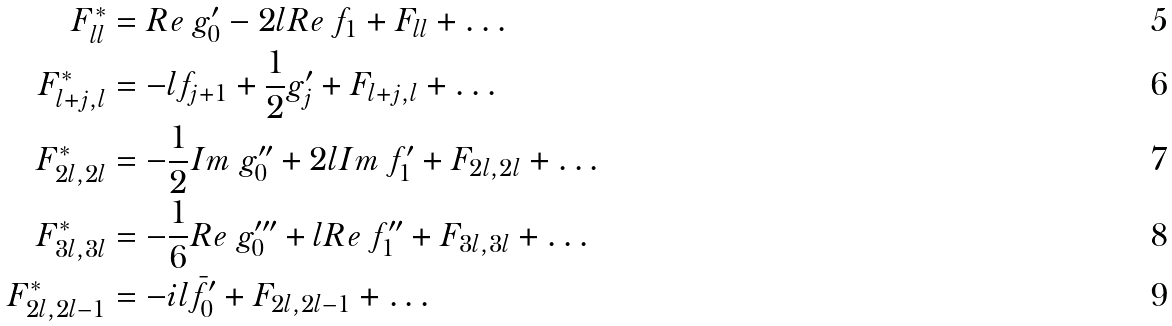<formula> <loc_0><loc_0><loc_500><loc_500>F ^ { * } _ { l l } & = R e \ g ^ { \prime } _ { 0 } - 2 l R e \ f _ { 1 } + F _ { l l } + \dots \\ F ^ { * } _ { l + j , l } & = - l f _ { j + 1 } + \frac { 1 } { 2 } g ^ { \prime } _ { j } + F _ { l + j , l } + \dots \\ F ^ { * } _ { 2 l , 2 l } & = - \frac { 1 } { 2 } I m \ g ^ { \prime \prime } _ { 0 } + 2 l I m \ f ^ { \prime } _ { 1 } + F _ { 2 l , 2 l } + \dots \\ F ^ { * } _ { 3 l , 3 l } & = - \frac { 1 } { 6 } R e \ g ^ { \prime \prime \prime } _ { 0 } + l R e \ f ^ { \prime \prime } _ { 1 } + F _ { 3 l , 3 l } + \dots \\ F ^ { * } _ { 2 l , 2 l - 1 } & = - i l \bar { f } ^ { \prime } _ { 0 } + F _ { 2 l , 2 l - 1 } + \dots \</formula> 